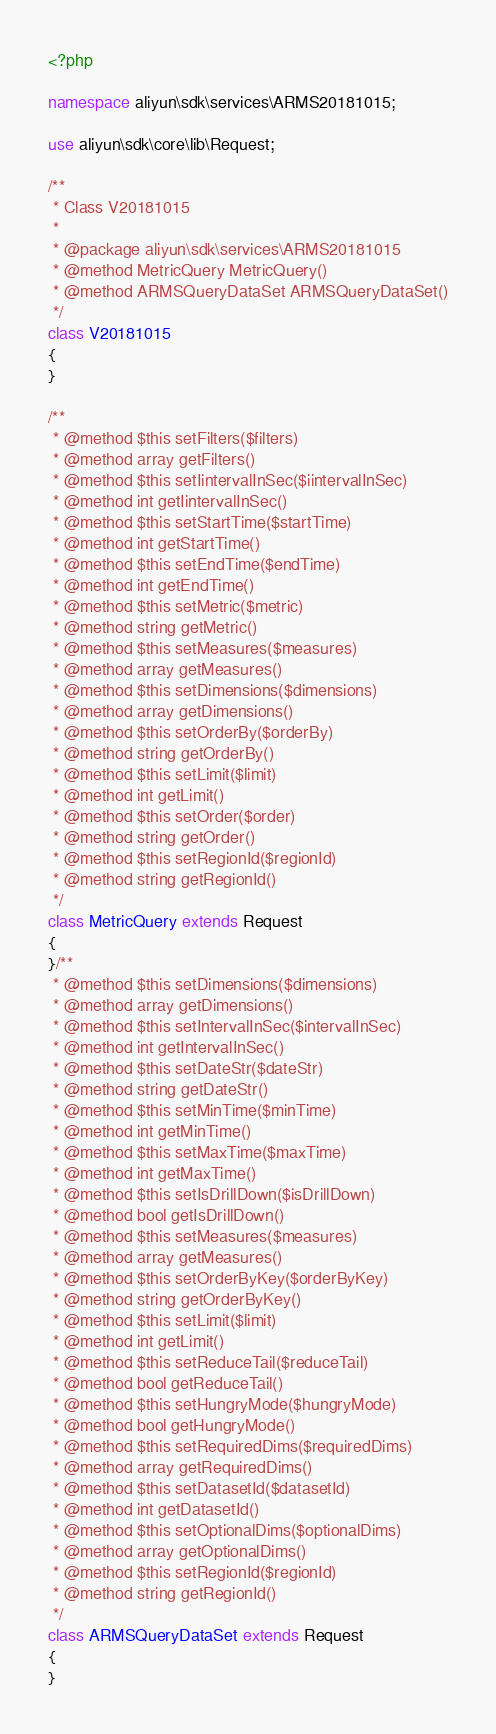<code> <loc_0><loc_0><loc_500><loc_500><_PHP_><?php

namespace aliyun\sdk\services\ARMS20181015;

use aliyun\sdk\core\lib\Request;

/**
 * Class V20181015
 *
 * @package aliyun\sdk\services\ARMS20181015
 * @method MetricQuery MetricQuery()
 * @method ARMSQueryDataSet ARMSQueryDataSet()
 */
class V20181015
{
}

/**
 * @method $this setFilters($filters)
 * @method array getFilters()
 * @method $this setIintervalInSec($iintervalInSec)
 * @method int getIintervalInSec()
 * @method $this setStartTime($startTime)
 * @method int getStartTime()
 * @method $this setEndTime($endTime)
 * @method int getEndTime()
 * @method $this setMetric($metric)
 * @method string getMetric()
 * @method $this setMeasures($measures)
 * @method array getMeasures()
 * @method $this setDimensions($dimensions)
 * @method array getDimensions()
 * @method $this setOrderBy($orderBy)
 * @method string getOrderBy()
 * @method $this setLimit($limit)
 * @method int getLimit()
 * @method $this setOrder($order)
 * @method string getOrder()
 * @method $this setRegionId($regionId)
 * @method string getRegionId()
 */
class MetricQuery extends Request
{
}/**
 * @method $this setDimensions($dimensions)
 * @method array getDimensions()
 * @method $this setIntervalInSec($intervalInSec)
 * @method int getIntervalInSec()
 * @method $this setDateStr($dateStr)
 * @method string getDateStr()
 * @method $this setMinTime($minTime)
 * @method int getMinTime()
 * @method $this setMaxTime($maxTime)
 * @method int getMaxTime()
 * @method $this setIsDrillDown($isDrillDown)
 * @method bool getIsDrillDown()
 * @method $this setMeasures($measures)
 * @method array getMeasures()
 * @method $this setOrderByKey($orderByKey)
 * @method string getOrderByKey()
 * @method $this setLimit($limit)
 * @method int getLimit()
 * @method $this setReduceTail($reduceTail)
 * @method bool getReduceTail()
 * @method $this setHungryMode($hungryMode)
 * @method bool getHungryMode()
 * @method $this setRequiredDims($requiredDims)
 * @method array getRequiredDims()
 * @method $this setDatasetId($datasetId)
 * @method int getDatasetId()
 * @method $this setOptionalDims($optionalDims)
 * @method array getOptionalDims()
 * @method $this setRegionId($regionId)
 * @method string getRegionId()
 */
class ARMSQueryDataSet extends Request
{
}
</code> 